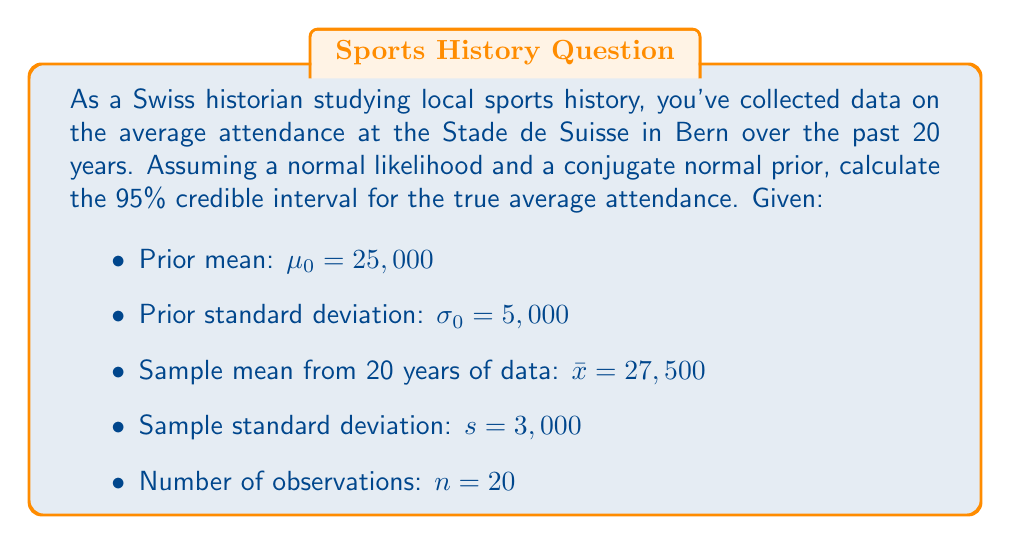Teach me how to tackle this problem. To calculate the credible interval, we'll use the posterior distribution, which combines our prior beliefs with the observed data. For a normal likelihood with a conjugate normal prior, the posterior distribution is also normal.

Step 1: Calculate the posterior mean ($\mu_n$)
The posterior mean is a weighted average of the prior mean and the sample mean:

$$\mu_n = \frac{\frac{\mu_0}{\sigma_0^2} + \frac{n\bar{x}}{s^2}}{\frac{1}{\sigma_0^2} + \frac{n}{s^2}}$$

Step 2: Calculate the posterior precision ($\tau_n^2$)
The posterior precision is the sum of the prior precision and the data precision:

$$\tau_n^2 = \frac{1}{\sigma_0^2} + \frac{n}{s^2}$$

Step 3: Calculate the posterior standard deviation ($\sigma_n$)
The posterior standard deviation is the inverse of the square root of the precision:

$$\sigma_n = \frac{1}{\sqrt{\tau_n^2}}$$

Step 4: Calculate the values
Substituting the given values:

$$\mu_n = \frac{\frac{25,000}{5,000^2} + \frac{20 \cdot 27,500}{3,000^2}}{\frac{1}{5,000^2} + \frac{20}{3,000^2}} \approx 27,321$$

$$\tau_n^2 = \frac{1}{5,000^2} + \frac{20}{3,000^2} \approx 2.26 \times 10^{-6}$$

$$\sigma_n = \frac{1}{\sqrt{2.26 \times 10^{-6}}} \approx 665$$

Step 5: Calculate the 95% credible interval
For a 95% credible interval, we use the z-score of approximately 1.96:

$$\text{Credible Interval} = \mu_n \pm 1.96 \cdot \sigma_n$$

Lower bound: $27,321 - 1.96 \cdot 665 \approx 26,018$
Upper bound: $27,321 + 1.96 \cdot 665 \approx 28,624$
Answer: The 95% credible interval for the true average attendance at the Stade de Suisse is approximately (26,018, 28,624). 